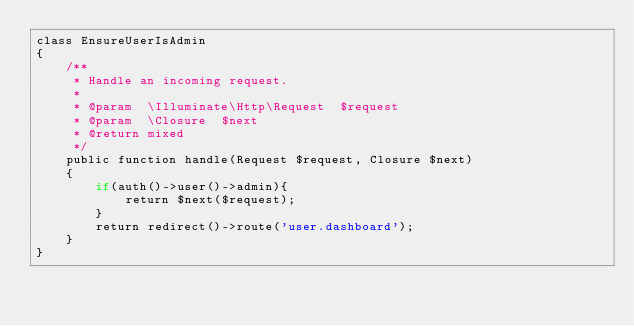<code> <loc_0><loc_0><loc_500><loc_500><_PHP_>class EnsureUserIsAdmin
{
    /**
     * Handle an incoming request.
     *
     * @param  \Illuminate\Http\Request  $request
     * @param  \Closure  $next
     * @return mixed
     */
    public function handle(Request $request, Closure $next)
    {
        if(auth()->user()->admin){
            return $next($request);
        }
        return redirect()->route('user.dashboard');
    }
}
</code> 